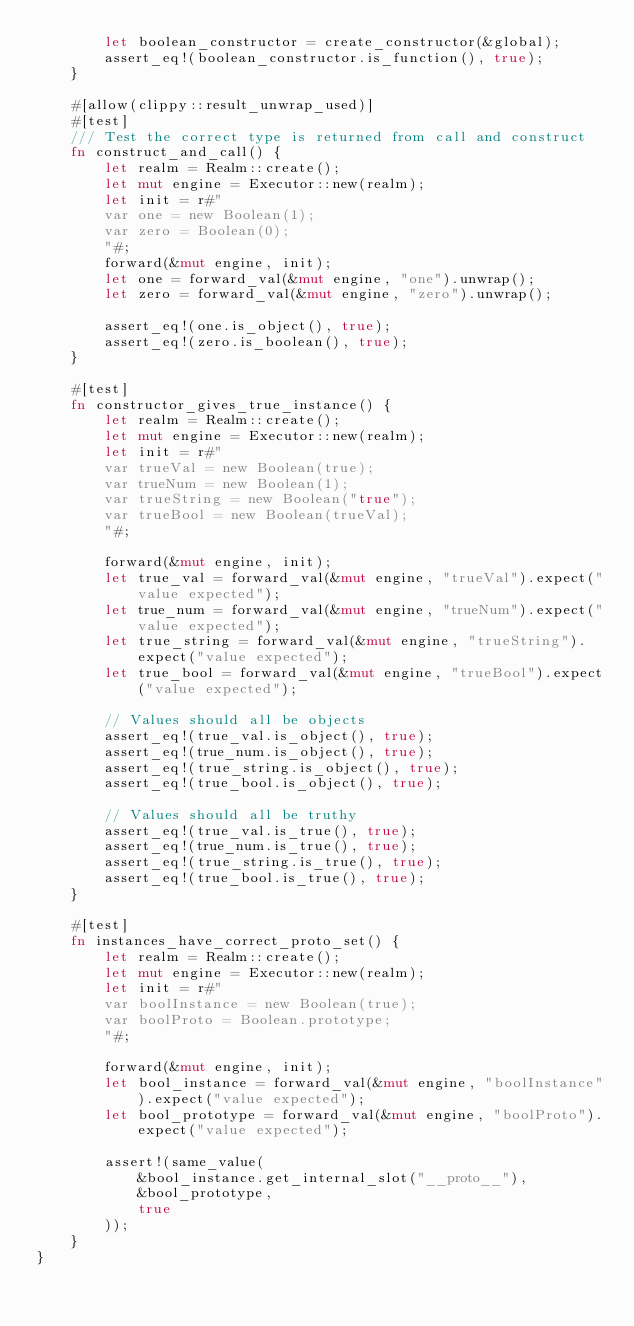<code> <loc_0><loc_0><loc_500><loc_500><_Rust_>        let boolean_constructor = create_constructor(&global);
        assert_eq!(boolean_constructor.is_function(), true);
    }

    #[allow(clippy::result_unwrap_used)]
    #[test]
    /// Test the correct type is returned from call and construct
    fn construct_and_call() {
        let realm = Realm::create();
        let mut engine = Executor::new(realm);
        let init = r#"
        var one = new Boolean(1);
        var zero = Boolean(0);
        "#;
        forward(&mut engine, init);
        let one = forward_val(&mut engine, "one").unwrap();
        let zero = forward_val(&mut engine, "zero").unwrap();

        assert_eq!(one.is_object(), true);
        assert_eq!(zero.is_boolean(), true);
    }

    #[test]
    fn constructor_gives_true_instance() {
        let realm = Realm::create();
        let mut engine = Executor::new(realm);
        let init = r#"
        var trueVal = new Boolean(true);
        var trueNum = new Boolean(1);
        var trueString = new Boolean("true");
        var trueBool = new Boolean(trueVal);
        "#;

        forward(&mut engine, init);
        let true_val = forward_val(&mut engine, "trueVal").expect("value expected");
        let true_num = forward_val(&mut engine, "trueNum").expect("value expected");
        let true_string = forward_val(&mut engine, "trueString").expect("value expected");
        let true_bool = forward_val(&mut engine, "trueBool").expect("value expected");

        // Values should all be objects
        assert_eq!(true_val.is_object(), true);
        assert_eq!(true_num.is_object(), true);
        assert_eq!(true_string.is_object(), true);
        assert_eq!(true_bool.is_object(), true);

        // Values should all be truthy
        assert_eq!(true_val.is_true(), true);
        assert_eq!(true_num.is_true(), true);
        assert_eq!(true_string.is_true(), true);
        assert_eq!(true_bool.is_true(), true);
    }

    #[test]
    fn instances_have_correct_proto_set() {
        let realm = Realm::create();
        let mut engine = Executor::new(realm);
        let init = r#"
        var boolInstance = new Boolean(true);
        var boolProto = Boolean.prototype;
        "#;

        forward(&mut engine, init);
        let bool_instance = forward_val(&mut engine, "boolInstance").expect("value expected");
        let bool_prototype = forward_val(&mut engine, "boolProto").expect("value expected");

        assert!(same_value(
            &bool_instance.get_internal_slot("__proto__"),
            &bool_prototype,
            true
        ));
    }
}
</code> 